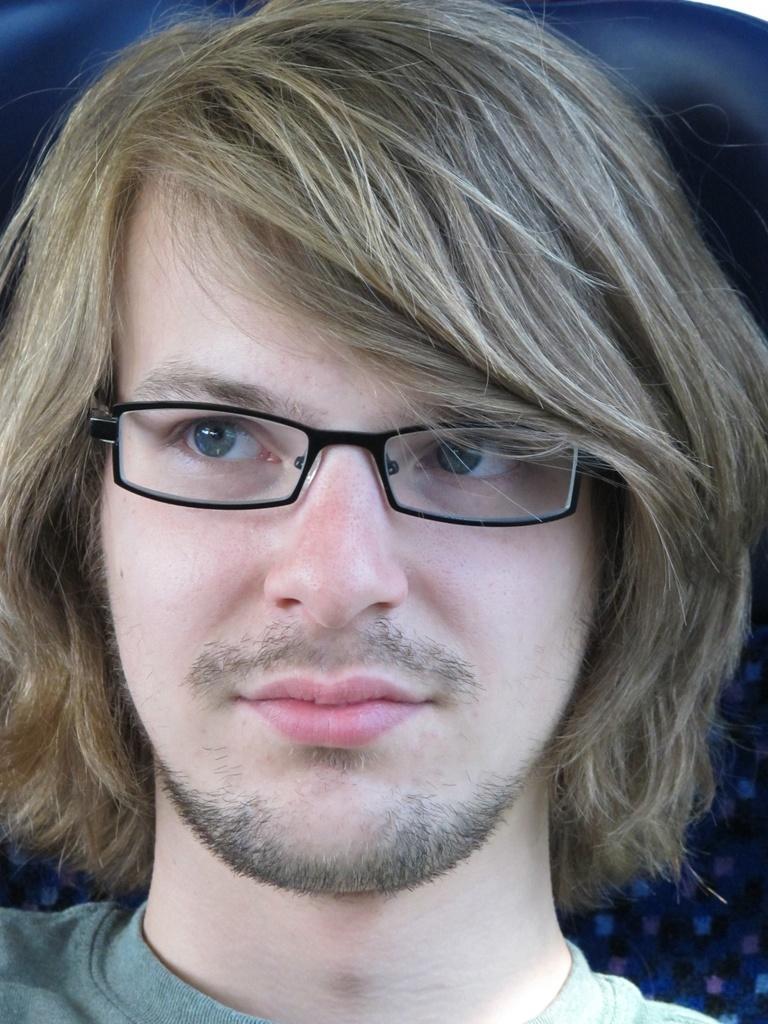Describe this image in one or two sentences. In this picture we can see a man, he wore spectacles. 